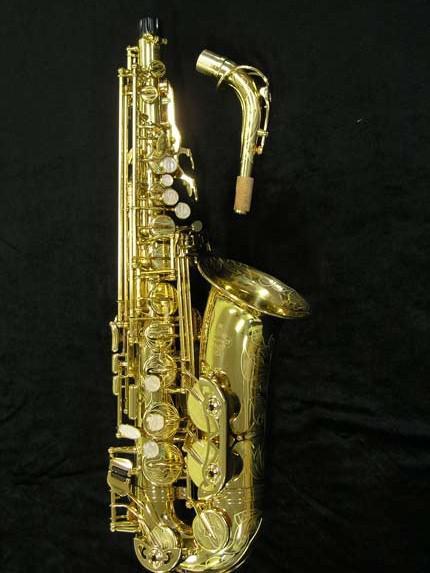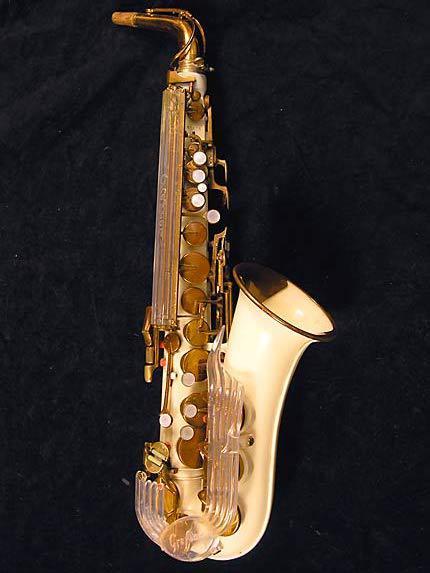The first image is the image on the left, the second image is the image on the right. For the images shown, is this caption "One image shows a saxophone displayed on black with its mouthpiece separated." true? Answer yes or no. Yes. The first image is the image on the left, the second image is the image on the right. Examine the images to the left and right. Is the description "In one image, a saxophone is shown in an upright position with the mouthpiece removed and placed beside it." accurate? Answer yes or no. Yes. 